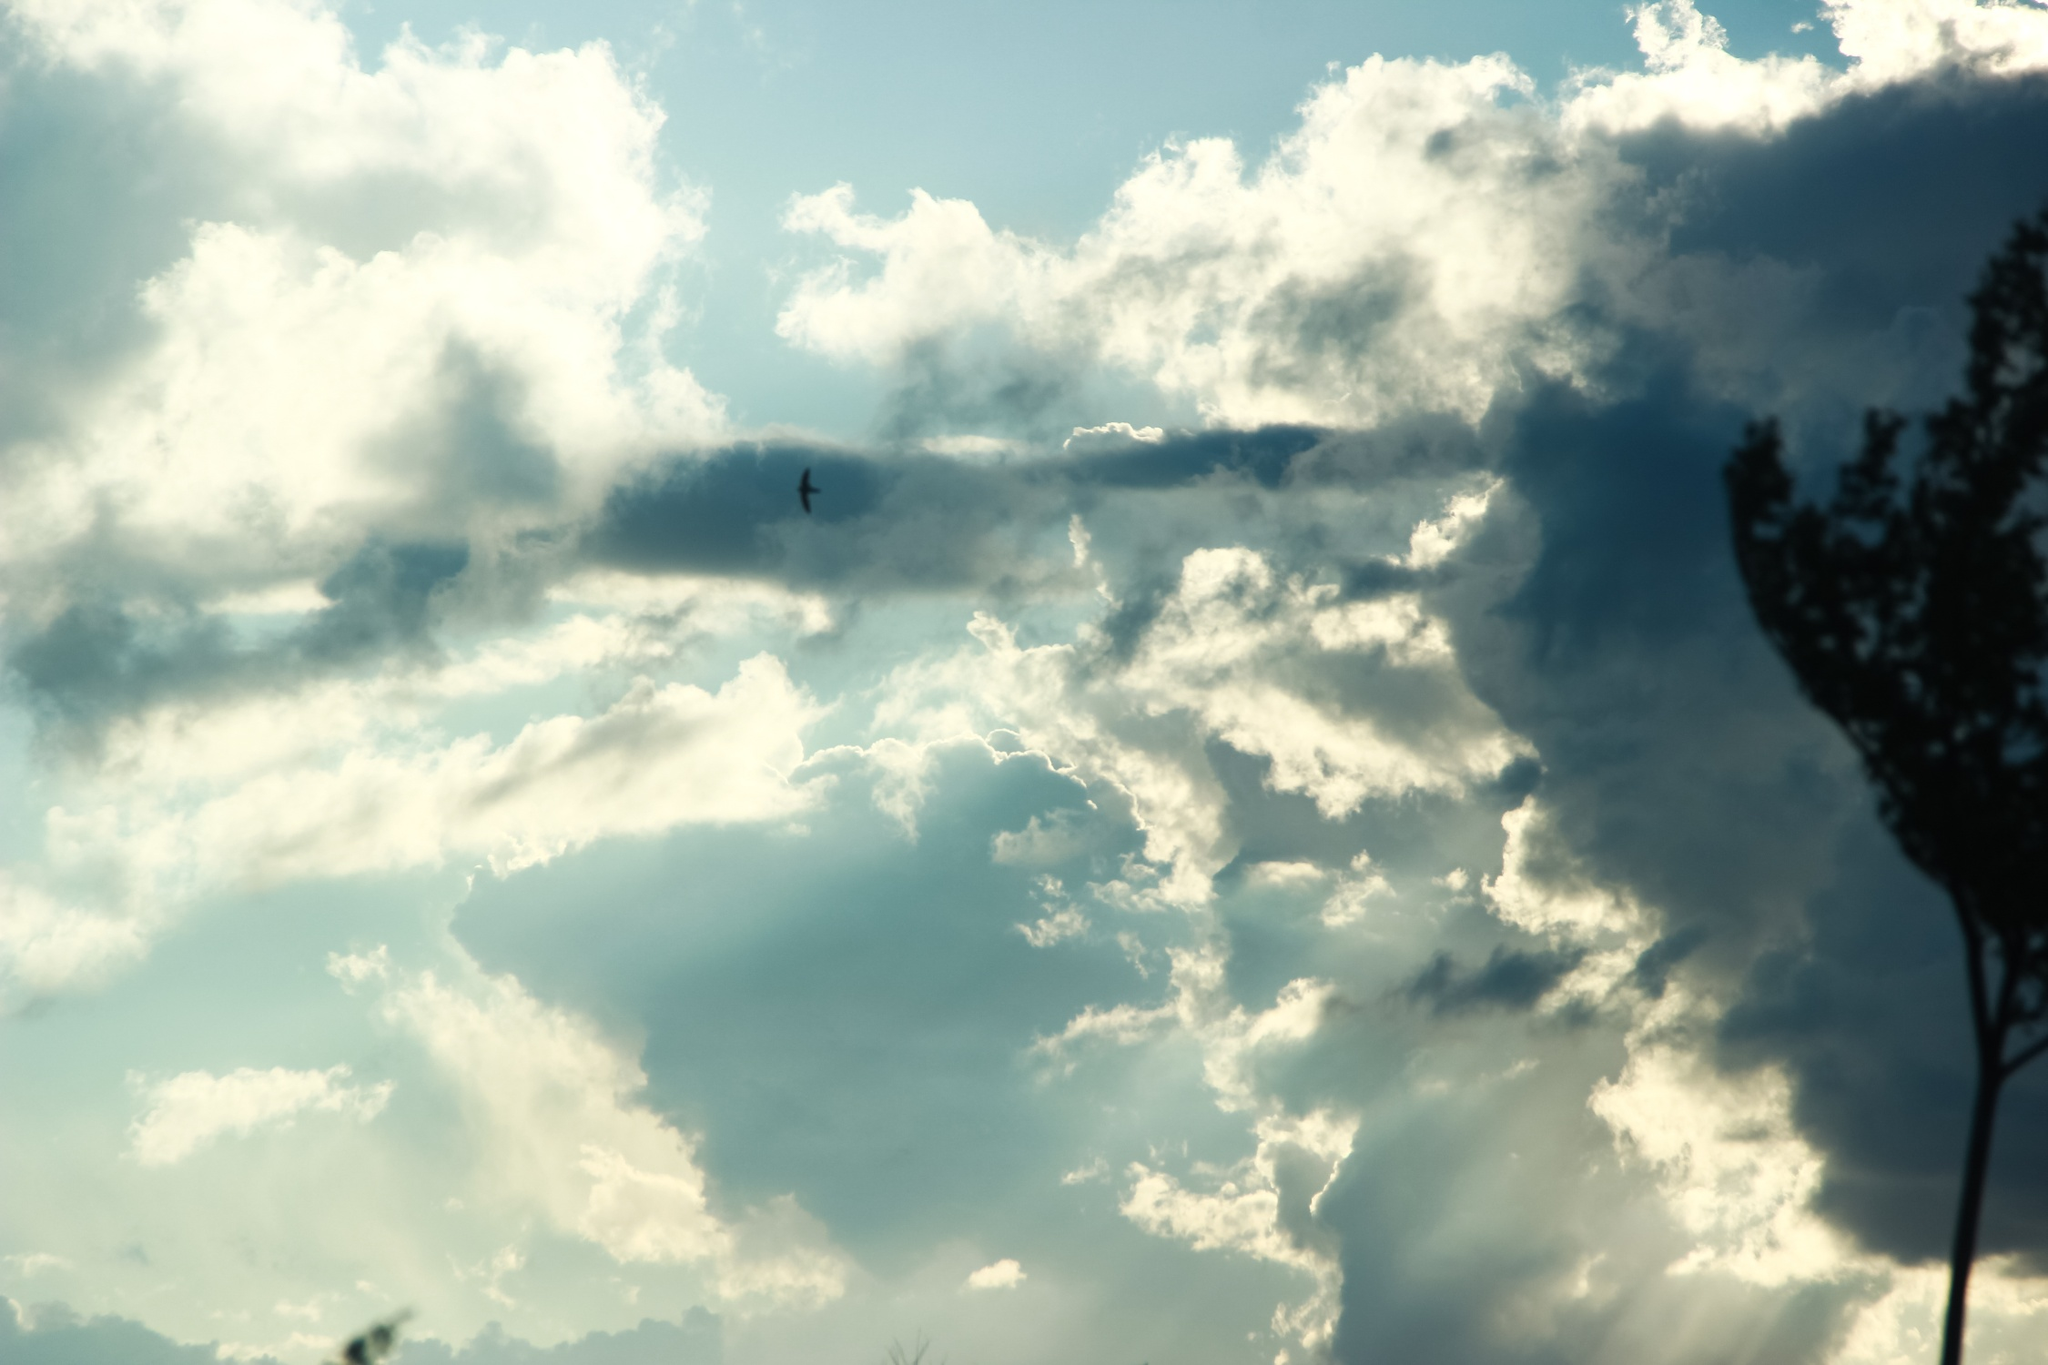Imagine this is an alien landscape. Describe the life forms that might inhabit it. On this alien world where the skies echo with an eternal symphony of ethereal beauty, life forms as unique as the landscape itself thrive. The towering tree, known as a Loomtree, is actually a sentient being, communicating through subtle rustling of its branches and emitting bioluminescent signals. The clouds above are home to airy creatures called Skydrifters, resembling immense jellyfish that glide effortlessly through vaporous waves. Hovering near the Loomtree are Humming Ailerons, small winged creatures with iridescent wings that shimmer like liquid crystal. They feed on the luminous nectar produced by the tree during its nightly glow. Ascending higher, the atmosphere is teeming with Lumispawns—ethereal beings composed of both light and matter, visible as shimmers that dance joyfully across the sky. These beings appear only in the presence of song induced by the hum of the Loomtree. Life here is a breathtaking interplay of light, sound, and symbiotic relationships, creating a world where every dawn is a signal for yet another dance of cosmic existence. 